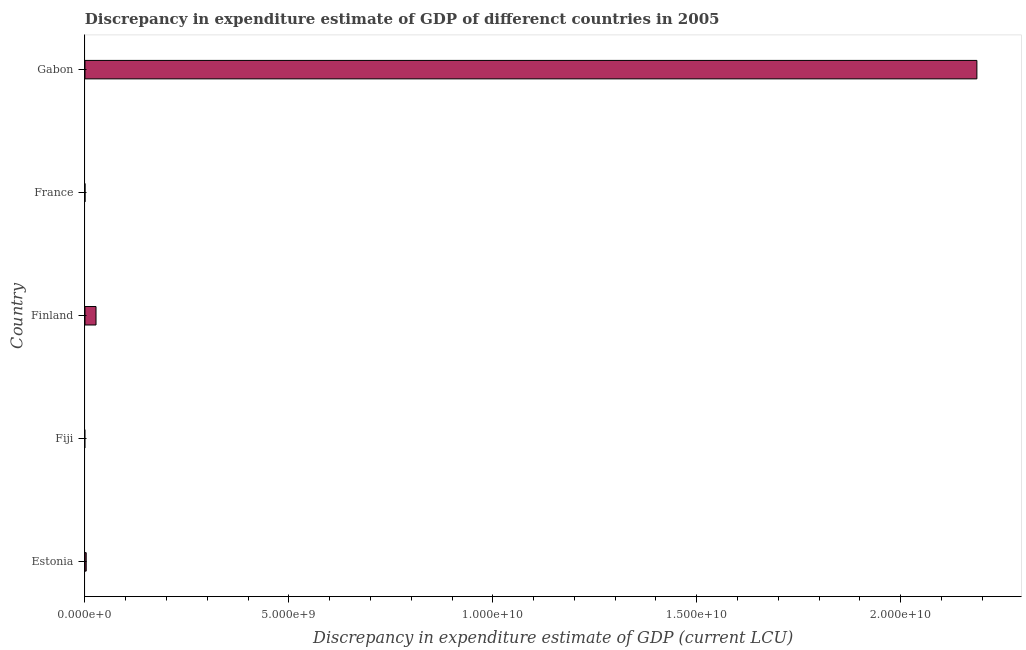Does the graph contain any zero values?
Provide a succinct answer. Yes. What is the title of the graph?
Make the answer very short. Discrepancy in expenditure estimate of GDP of differenct countries in 2005. What is the label or title of the X-axis?
Ensure brevity in your answer.  Discrepancy in expenditure estimate of GDP (current LCU). What is the discrepancy in expenditure estimate of gdp in Finland?
Provide a succinct answer. 2.71e+08. Across all countries, what is the maximum discrepancy in expenditure estimate of gdp?
Your answer should be very brief. 2.19e+1. In which country was the discrepancy in expenditure estimate of gdp maximum?
Your answer should be compact. Gabon. What is the sum of the discrepancy in expenditure estimate of gdp?
Offer a very short reply. 2.22e+1. What is the difference between the discrepancy in expenditure estimate of gdp in Estonia and Gabon?
Your answer should be very brief. -2.18e+1. What is the average discrepancy in expenditure estimate of gdp per country?
Offer a very short reply. 4.43e+09. What is the median discrepancy in expenditure estimate of gdp?
Ensure brevity in your answer.  3.02e+07. What is the ratio of the discrepancy in expenditure estimate of gdp in Estonia to that in Finland?
Keep it short and to the point. 0.11. Is the discrepancy in expenditure estimate of gdp in Estonia less than that in Finland?
Your answer should be very brief. Yes. What is the difference between the highest and the second highest discrepancy in expenditure estimate of gdp?
Make the answer very short. 2.16e+1. What is the difference between the highest and the lowest discrepancy in expenditure estimate of gdp?
Your answer should be very brief. 2.19e+1. In how many countries, is the discrepancy in expenditure estimate of gdp greater than the average discrepancy in expenditure estimate of gdp taken over all countries?
Provide a succinct answer. 1. How many bars are there?
Keep it short and to the point. 3. Are all the bars in the graph horizontal?
Your answer should be compact. Yes. What is the difference between two consecutive major ticks on the X-axis?
Offer a terse response. 5.00e+09. What is the Discrepancy in expenditure estimate of GDP (current LCU) of Estonia?
Make the answer very short. 3.02e+07. What is the Discrepancy in expenditure estimate of GDP (current LCU) in Fiji?
Your answer should be very brief. 0. What is the Discrepancy in expenditure estimate of GDP (current LCU) of Finland?
Keep it short and to the point. 2.71e+08. What is the Discrepancy in expenditure estimate of GDP (current LCU) of France?
Make the answer very short. 0. What is the Discrepancy in expenditure estimate of GDP (current LCU) of Gabon?
Your response must be concise. 2.19e+1. What is the difference between the Discrepancy in expenditure estimate of GDP (current LCU) in Estonia and Finland?
Offer a very short reply. -2.41e+08. What is the difference between the Discrepancy in expenditure estimate of GDP (current LCU) in Estonia and Gabon?
Your answer should be compact. -2.18e+1. What is the difference between the Discrepancy in expenditure estimate of GDP (current LCU) in Finland and Gabon?
Give a very brief answer. -2.16e+1. What is the ratio of the Discrepancy in expenditure estimate of GDP (current LCU) in Estonia to that in Finland?
Your answer should be compact. 0.11. What is the ratio of the Discrepancy in expenditure estimate of GDP (current LCU) in Estonia to that in Gabon?
Your answer should be compact. 0. What is the ratio of the Discrepancy in expenditure estimate of GDP (current LCU) in Finland to that in Gabon?
Give a very brief answer. 0.01. 